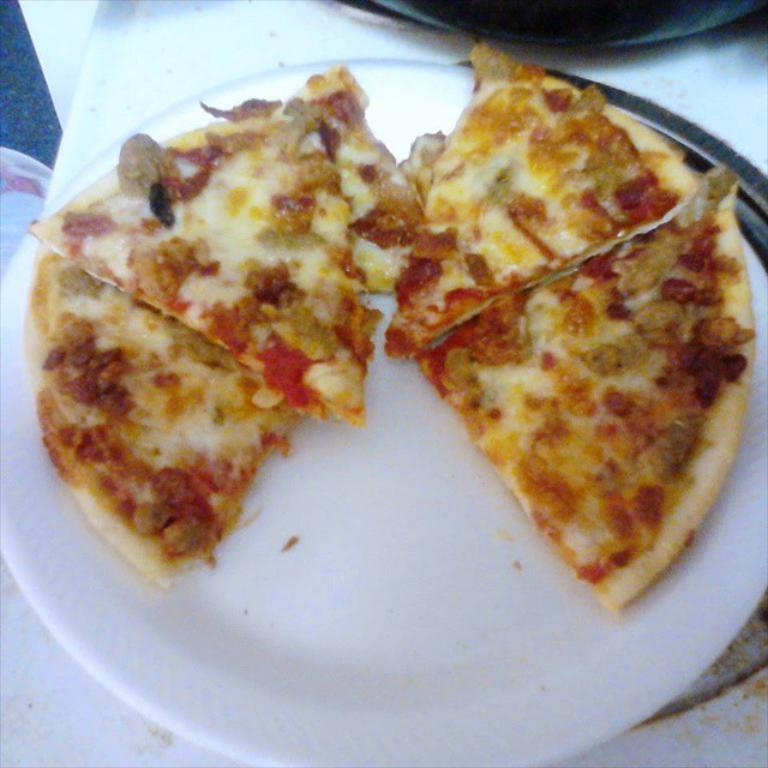What type of food is on the plate in the image? There are pizza slices on a plate. Where is the plate located in the image? The plate is on a platform. How many flies are sitting on the pizza slices in the image? There are no flies present on the pizza slices in the image. What type of horn can be seen attached to the pizza slices in the image? There is no horn present on the pizza slices in the image. 